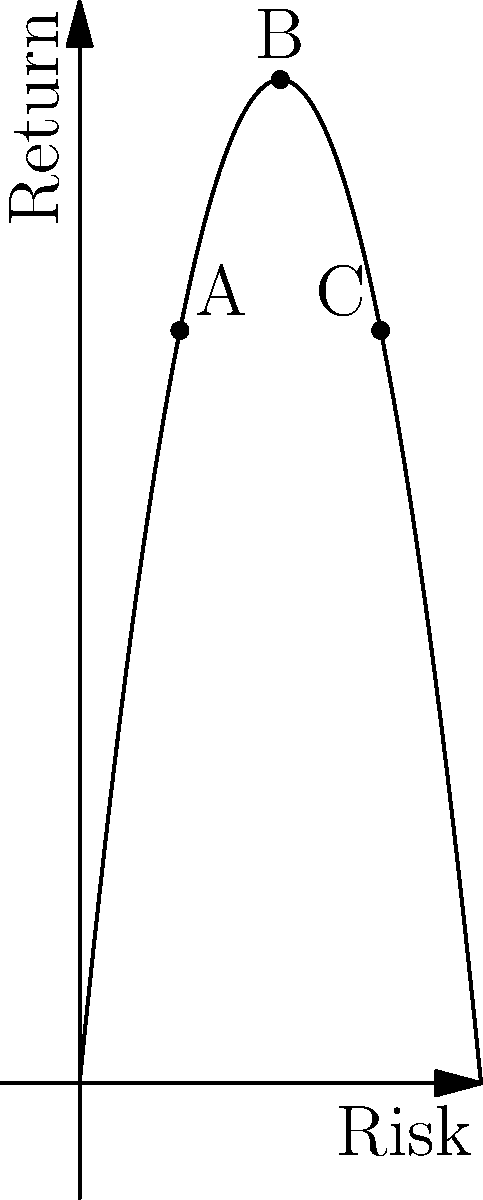The graph represents the risk-return trade-off for a diversified cryptocurrency portfolio, modeled by the function $R(x) = -0.5x^2 + 10x$, where $x$ is the risk level and $R(x)$ is the expected return. Points A, B, and C represent different portfolio compositions. At which point does the portfolio achieve its maximum expected return, and what is the corresponding risk level? To find the maximum expected return and corresponding risk level:

1) The function given is $R(x) = -0.5x^2 + 10x$

2) To find the maximum, we need to find where the derivative equals zero:
   $R'(x) = -x + 10$
   
3) Set $R'(x) = 0$:
   $-x + 10 = 0$
   $x = 10$

4) Confirm this is a maximum by checking the second derivative:
   $R''(x) = -1$ (negative, confirming a maximum)

5) The risk level at the maximum return is $x = 10$

6) Calculate the maximum return:
   $R(10) = -0.5(10)^2 + 10(10) = -50 + 100 = 50$

7) On the graph, this corresponds to point B, where the curve reaches its peak.

Therefore, the portfolio achieves its maximum expected return at point B, where the risk level is 10 and the expected return is 50.
Answer: Point B; Risk level: 10 